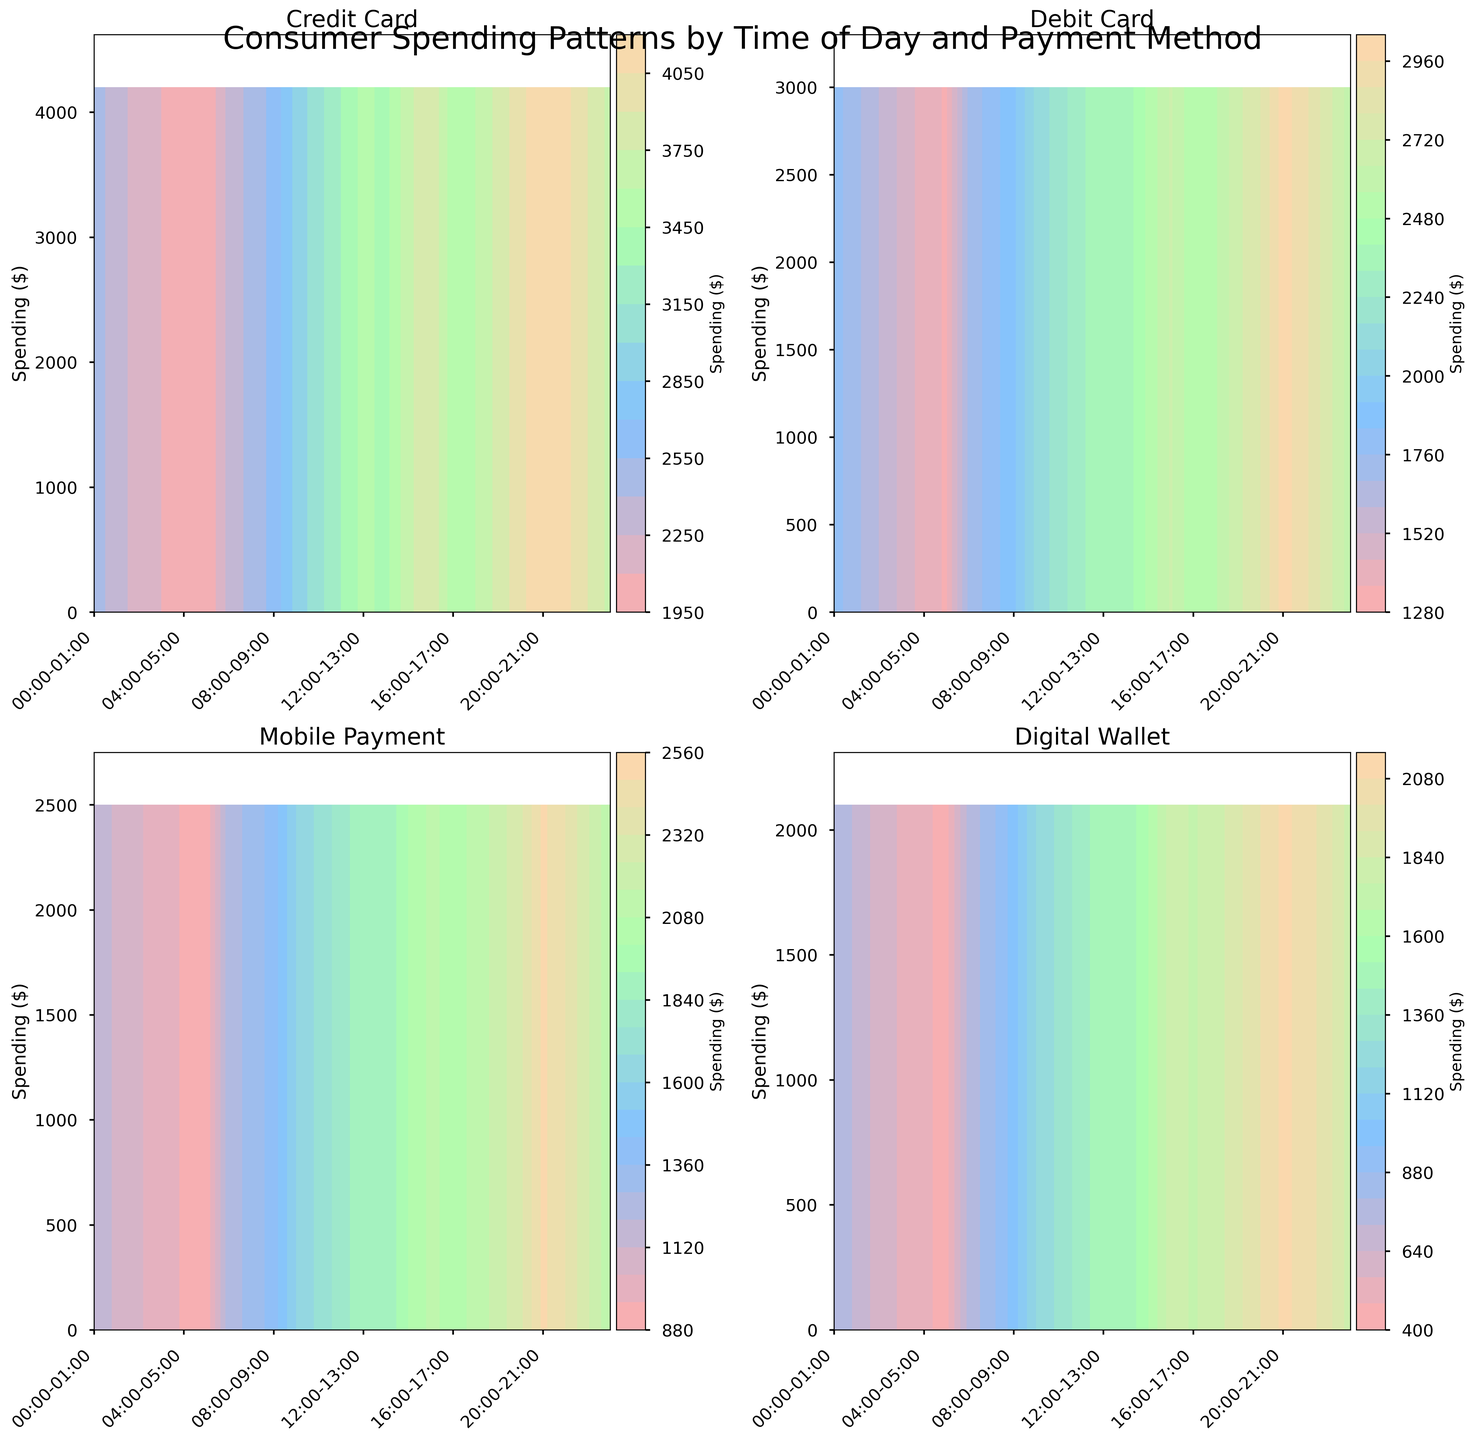What is the title of the figure? The title of the figure is usually found at the top center. Look at the top center part of the figure to find the title.
Answer: Consumer Spending Patterns by Time of Day and Payment Method How many subplots are in the figure? The figure contains subplots arranged in a grid format. Count the number of separate plots within the entire figure.
Answer: 4 Which payment method has the highest consumer spending from 09:00-10:00? Look at each subplot and find the one corresponding to 09:00-10:00. Identify the payment method with the highest contour levels during this time period.
Answer: Credit Card Is there any time slot where Mobile Payment shows higher consumer spending than Debit Card? Compare the subplots for Mobile Payment and Debit Card across all time slots to check if Mobile Payment has higher spending at any time.
Answer: No What is the maximum spending value for Digital Wallet? Examine the subplot for Digital Wallet and look for the highest spending value indicated by the contour levels.
Answer: 2500 At what time of day does Consumer Spending for Credit Card peak? Look at the contour levels for Credit Card and identify the time slot where the spending value is the highest.
Answer: 20:00-21:00 Which payment method has the most consistent spending pattern throughout the day? Check the contour levels across all time slots for each payment method and see which one shows less fluctuation.
Answer: Debit Card Does consumer spending increase or decrease throughout the day for Mobile Payment? Observe the contour levels in the Mobile Payment subplot from early hours to late hours to see the overall trend.
Answer: Increase How does consumer spending for Debit Card from 08:00-09:00 compare to 19:00-20:00? Find the spending values in the Debit Card subplot for both time slots and compare them to see which is higher.
Answer: 19:00-20:00 is higher What are the color shades used in the contours? Identify the visually prominent colors used in the contour plots. The shades represent spending levels.
Answer: Red, Blue, Green, Orange 